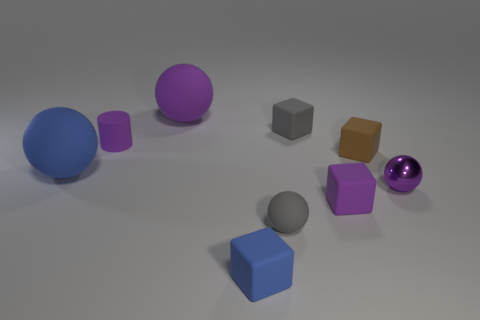What is the size of the thing that is both on the right side of the tiny gray rubber ball and behind the tiny cylinder?
Your answer should be compact. Small. Is the number of large matte objects that are to the right of the blue sphere greater than the number of small matte things that are behind the cylinder?
Offer a very short reply. No. What color is the other big object that is the same shape as the big purple rubber object?
Provide a succinct answer. Blue. There is a large rubber sphere that is on the left side of the large purple rubber object; does it have the same color as the metal ball?
Provide a succinct answer. No. What number of purple shiny objects are there?
Provide a short and direct response. 1. Are the tiny sphere that is left of the shiny sphere and the cylinder made of the same material?
Offer a terse response. Yes. Is there anything else that has the same material as the small blue block?
Provide a short and direct response. Yes. There is a purple ball that is in front of the large matte object that is in front of the small gray cube; what number of purple matte balls are right of it?
Offer a very short reply. 0. What is the size of the gray ball?
Keep it short and to the point. Small. Is the tiny metallic object the same color as the small rubber sphere?
Offer a terse response. No. 